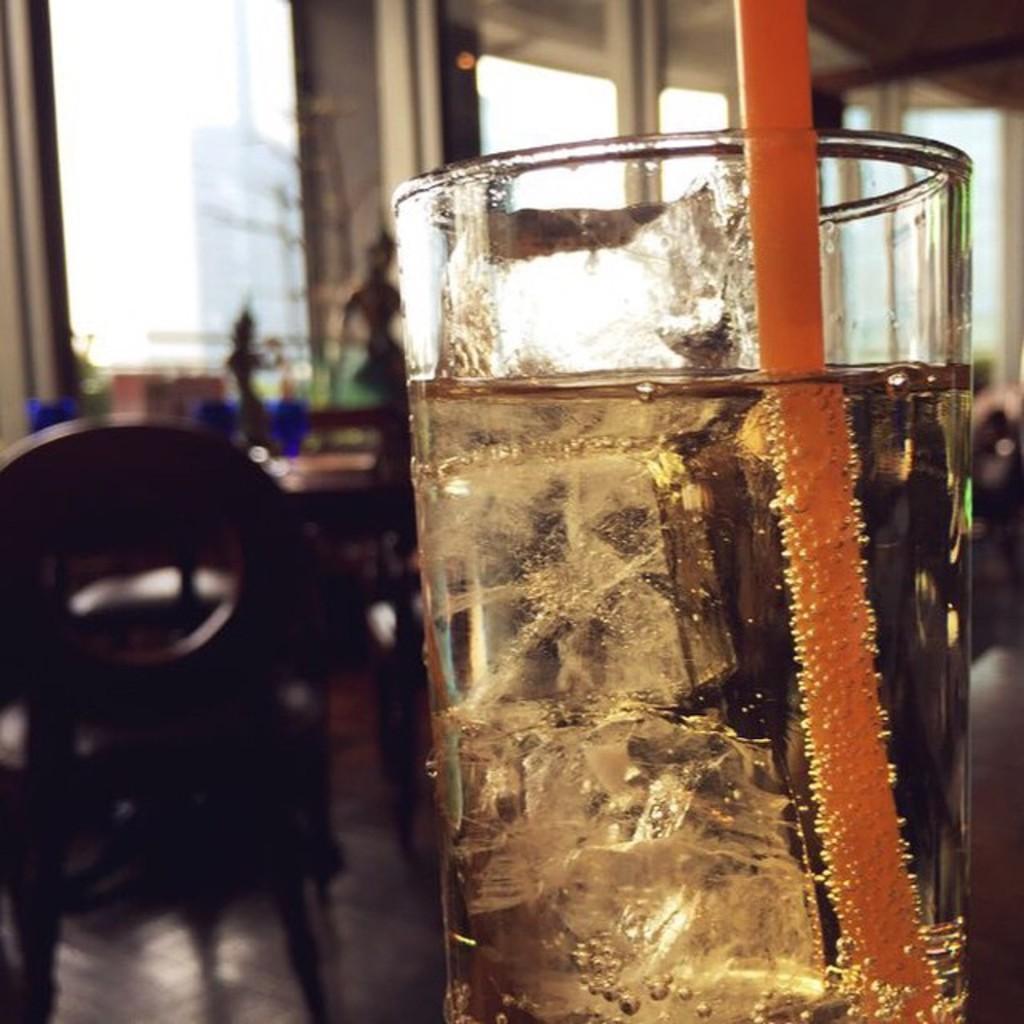How would you summarize this image in a sentence or two? In this image, I can see a glass of liquid with ice cubes and a straw. This looks like a chair. I can see few objects placed on the table. In the background, I think these are the glass doors. 